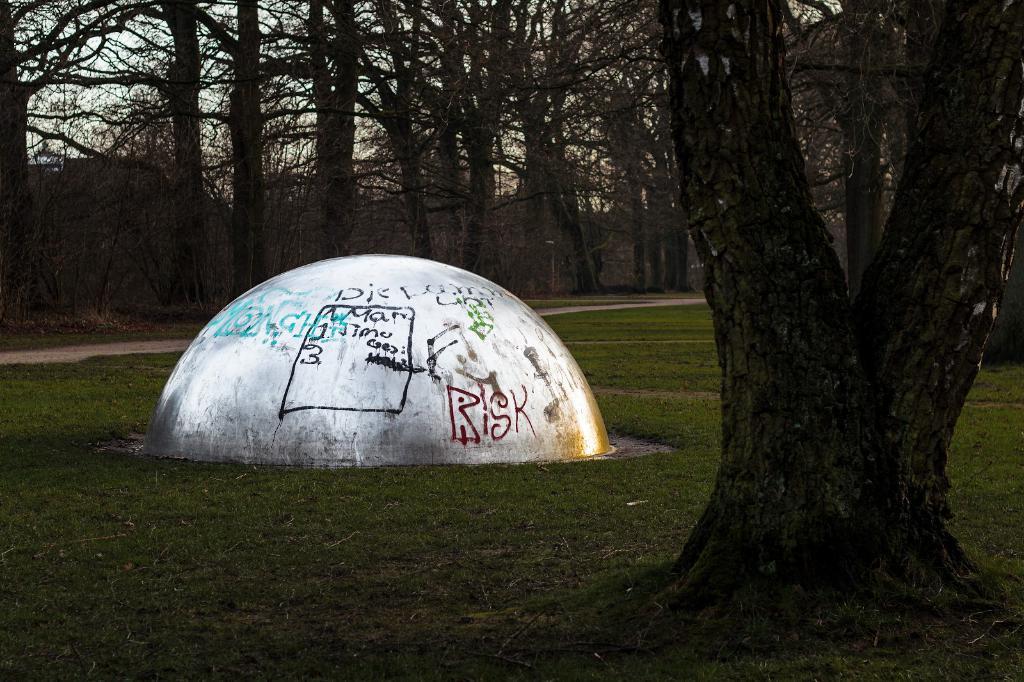In one or two sentences, can you explain what this image depicts? In this image we can see a stone wall on which we can see some text. Here we can see the grass, trees and the sky in the background. 